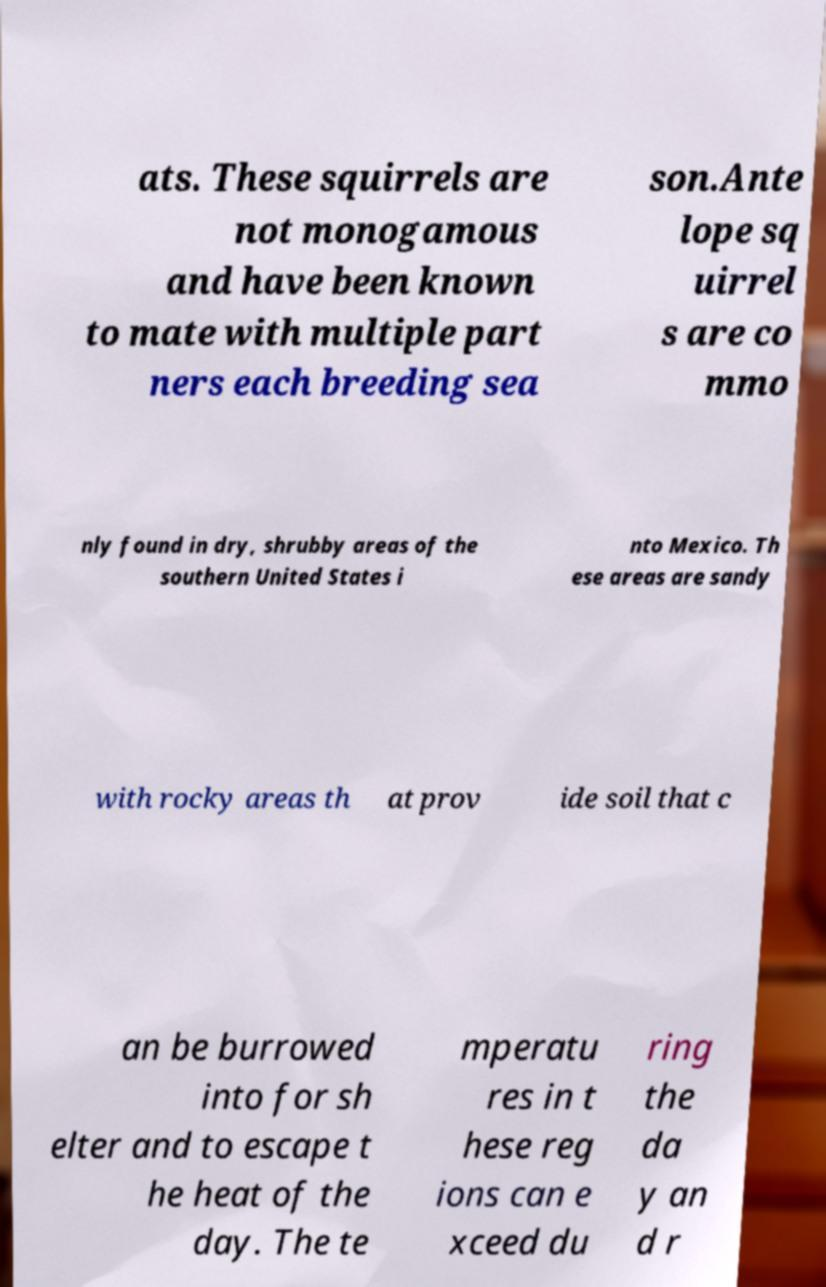Could you extract and type out the text from this image? ats. These squirrels are not monogamous and have been known to mate with multiple part ners each breeding sea son.Ante lope sq uirrel s are co mmo nly found in dry, shrubby areas of the southern United States i nto Mexico. Th ese areas are sandy with rocky areas th at prov ide soil that c an be burrowed into for sh elter and to escape t he heat of the day. The te mperatu res in t hese reg ions can e xceed du ring the da y an d r 